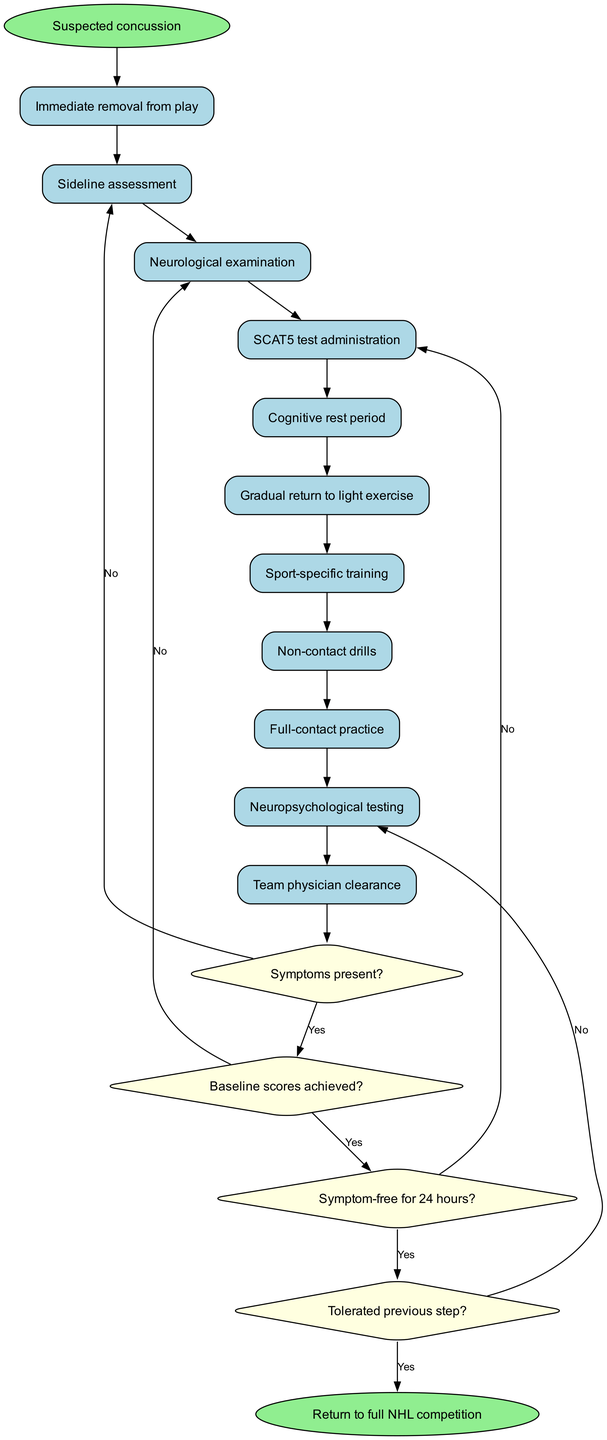What is the starting point of the diagram? The diagram begins with the node labeled "Suspected concussion," indicating the initial condition leading to the concussion management process.
Answer: Suspected concussion How many activities are listed in the diagram? There are 11 activities listed in the diagram, including steps from "Immediate removal from play" to "Team physician clearance."
Answer: 11 What is the first activity after the "Suspected concussion" node? Following the starting point, the first activity represented is "Immediate removal from play," which is critical for ensuring the athlete's safety.
Answer: Immediate removal from play What happens if symptoms are present after the "Sideline assessment"? If symptoms are present, it leads back to an appropriate follow-up, indicating that the athlete should not continue to the next step in the protocol.
Answer: No progression to the next step What is the decision made after the "Neuropsychological testing"? The decision node after this testing is to check if the athlete is symptom-free for 24 hours, which is crucial for the next steps toward return to play.
Answer: Symptom-free for 24 hours? What is the last activity before the final decision in the diagram? The last activity prior to the final decision is "Team physician clearance," which is essential for determining if the athlete can return to full competition.
Answer: Team physician clearance How many decisions are made throughout the protocol? There are 4 decision nodes present in the protocol, which assess the athlete's condition at various points in the process.
Answer: 4 What is the endpoint of the activity diagram? The endpoint of the diagram is "Return to full NHL competition," which signifies that all necessary requirements have been met for the athlete to resume gameplay.
Answer: Return to full NHL competition What is the process after "Cognitive rest period" if symptoms are not resolved? If symptoms are not resolved, the process typically leads back to further evaluations and rest, without advancing to light exercise.
Answer: No progression to the next step 